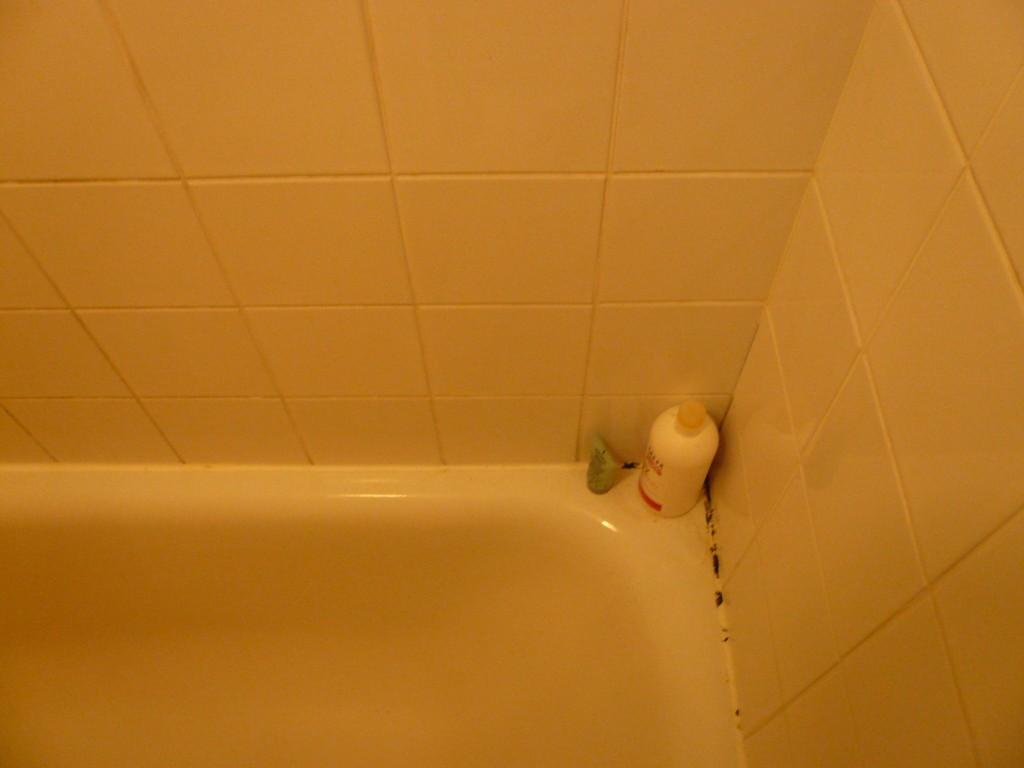What is located at the bottom of the image? There is a bathtub at the bottom of the image. What can be seen on the surface of the bathtub? There is a bottle and a tube on the surface of the bathtub. What is the material of the wall near the bathtub? The wall near the bathtub has tiles. How much debt is visible in the image? There is no mention of debt in the image, as it features a bathtub with a bottle and a tube on its surface, and tiled walls. 